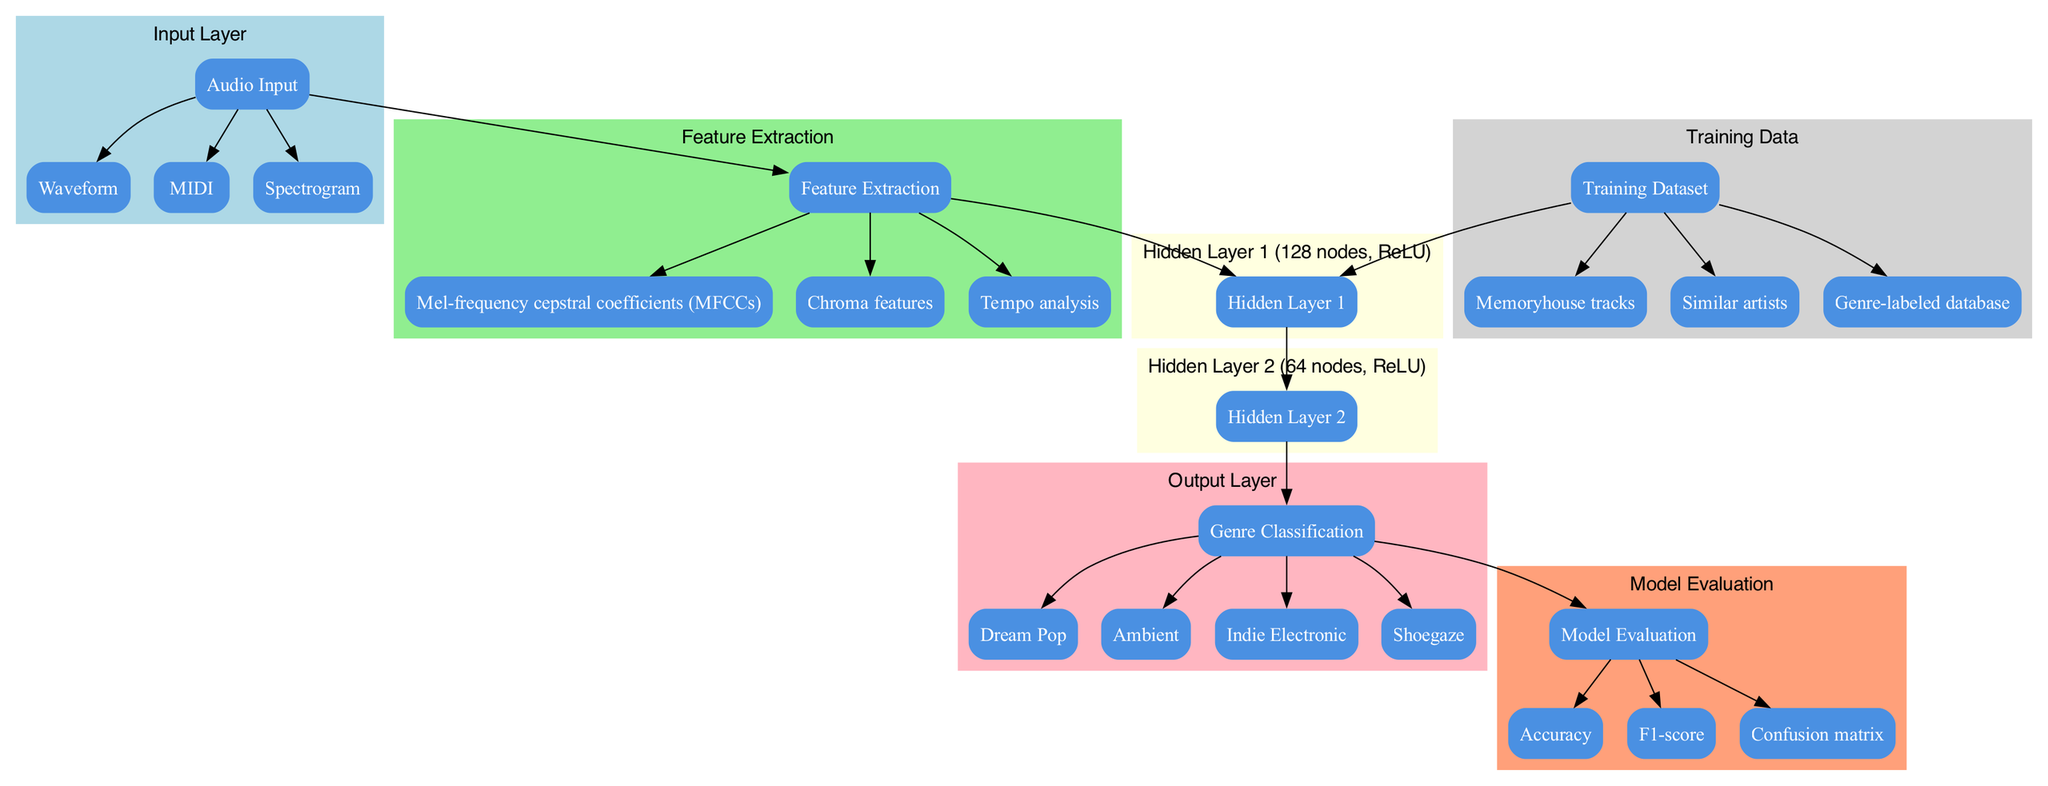What is the name of the output layer? The diagram identifies the output layer as "Genre Classification." This can be found under the Output Layer section of the diagram.
Answer: Genre Classification How many nodes are in Hidden Layer 1? Hidden Layer 1 has 128 nodes, as indicated within the description of that layer in the diagram.
Answer: 128 What are the techniques used for feature extraction? The feature extraction techniques listed in the diagram include "Mel-frequency cepstral coefficients (MFCCs)," "Chroma features," and "Tempo analysis." These are shown under the Feature Extraction section.
Answer: Mel-frequency cepstral coefficients (MFCCs), Chroma features, Tempo analysis Which genres are included in the output layer? The output layer lists the genres as "Dream Pop," "Ambient," "Indie Electronic," and "Shoegaze." This information is found in the output layer section of the diagram.
Answer: Dream Pop, Ambient, Indie Electronic, Shoegaze What is the activation function used in Hidden Layer 2? The activation function for Hidden Layer 2, as specified in the diagram, is "ReLU." This information is clearly presented in the layer's description.
Answer: ReLU How many sources are listed under the Training Dataset? There are three sources listed under the Training Dataset in the diagram which are "Memoryhouse tracks," "Similar artists," and "Genre-labeled database." This can be counted from the Training Data section of the diagram.
Answer: 3 Which metric is used in Model Evaluation? The diagram lists "Accuracy," "F1-score," and "Confusion matrix" as metrics in the Model Evaluation section. This means any of these could be referred to; however, if we're looking for just one, "Accuracy" is the first mentioned metric.
Answer: Accuracy What is the primary purpose of the diagram? The primary purpose of this diagram is to illustrate the "Neural Network for Music Genre Classification." This is described in the title of the diagram itself.
Answer: Neural Network for Music Genre Classification How many hidden layers are present in the model? The diagram indicates that there are two hidden layers, labeled as Hidden Layer 1 and Hidden Layer 2. This is deduced from examining the hidden layers' section of the diagram.
Answer: 2 